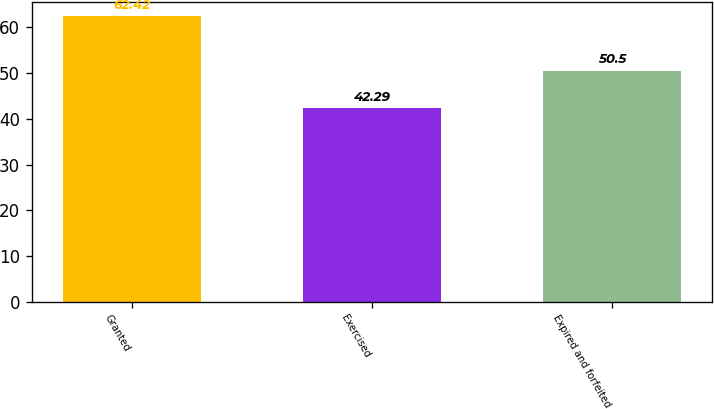Convert chart. <chart><loc_0><loc_0><loc_500><loc_500><bar_chart><fcel>Granted<fcel>Exercised<fcel>Expired and forfeited<nl><fcel>62.42<fcel>42.29<fcel>50.5<nl></chart> 